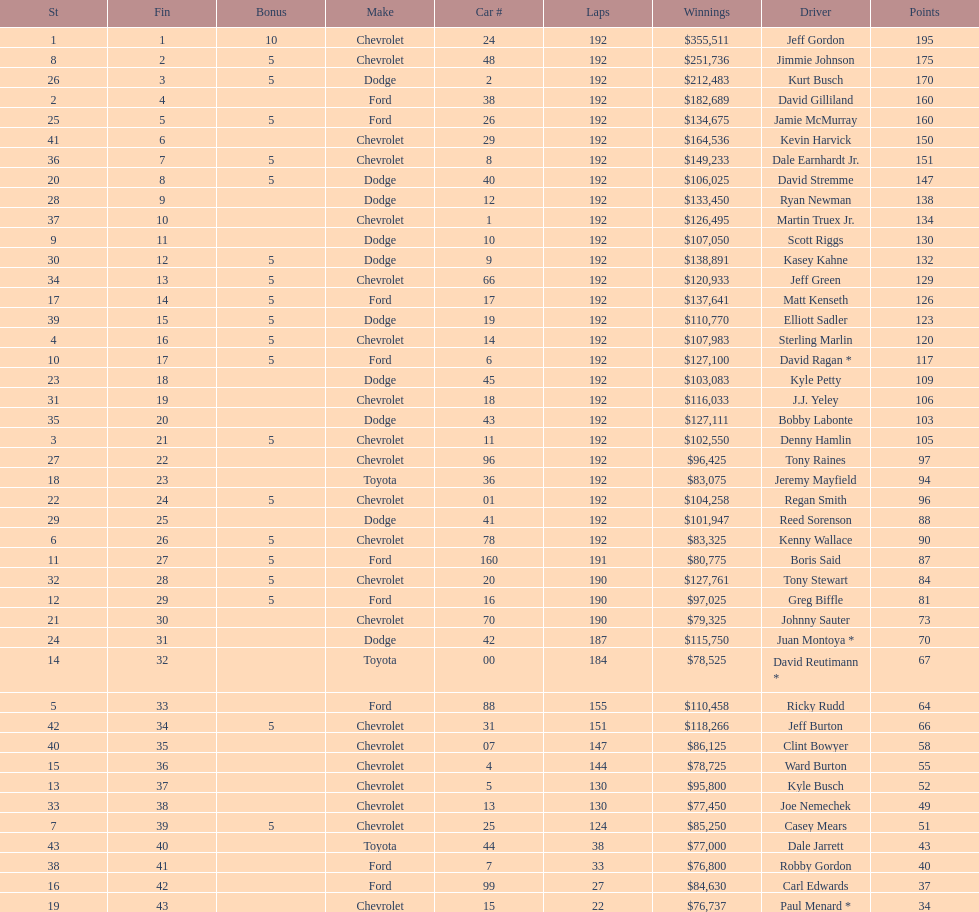How many drivers earned no bonus for this race? 23. 